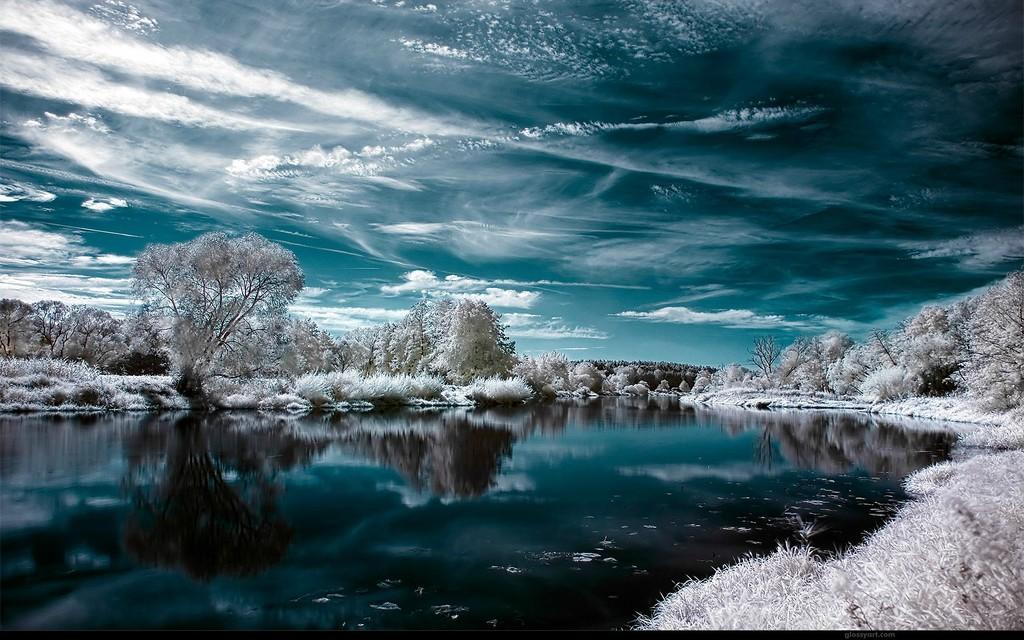Can you describe this image briefly? In this image we can see a water body, some plants, a group of trees and the sky which looks cloudy. 